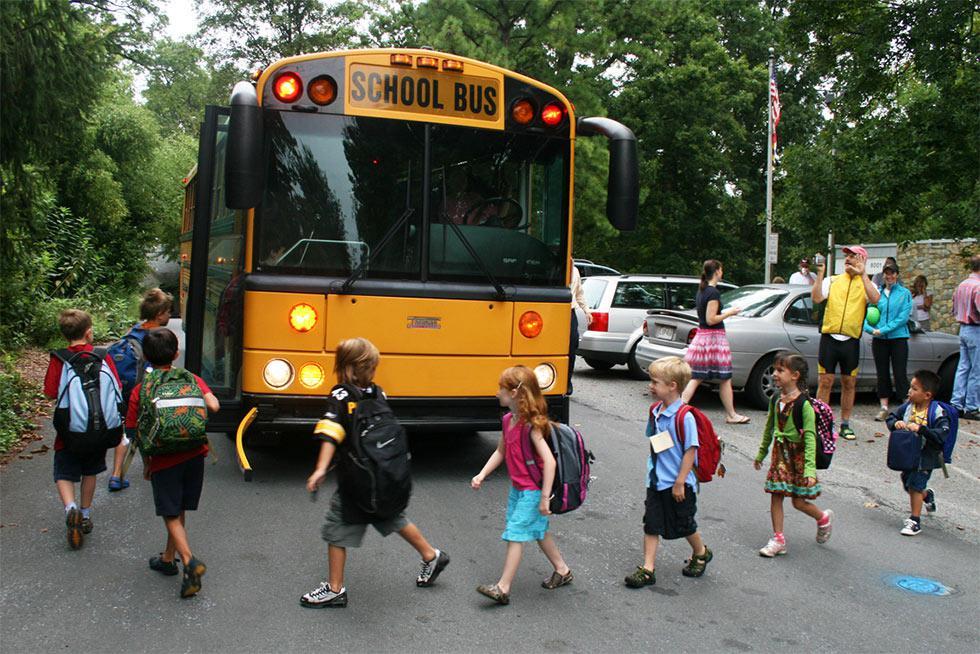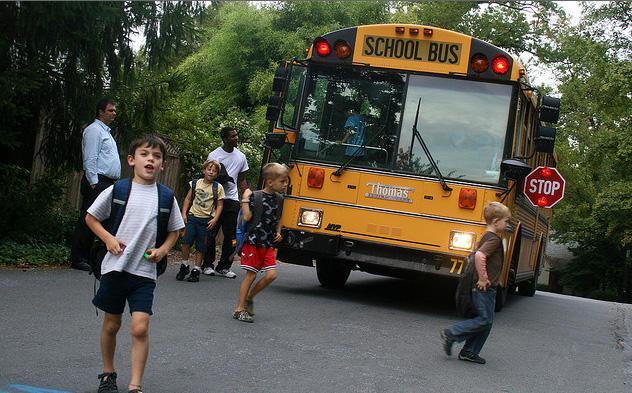The first image is the image on the left, the second image is the image on the right. Considering the images on both sides, is "The left and right image contains the same number of buses facing frontward and backward." valid? Answer yes or no. No. The first image is the image on the left, the second image is the image on the right. Considering the images on both sides, is "An image shows a man standing to the left, and at least one child in front of the door of a flat-fronted school bus." valid? Answer yes or no. Yes. 